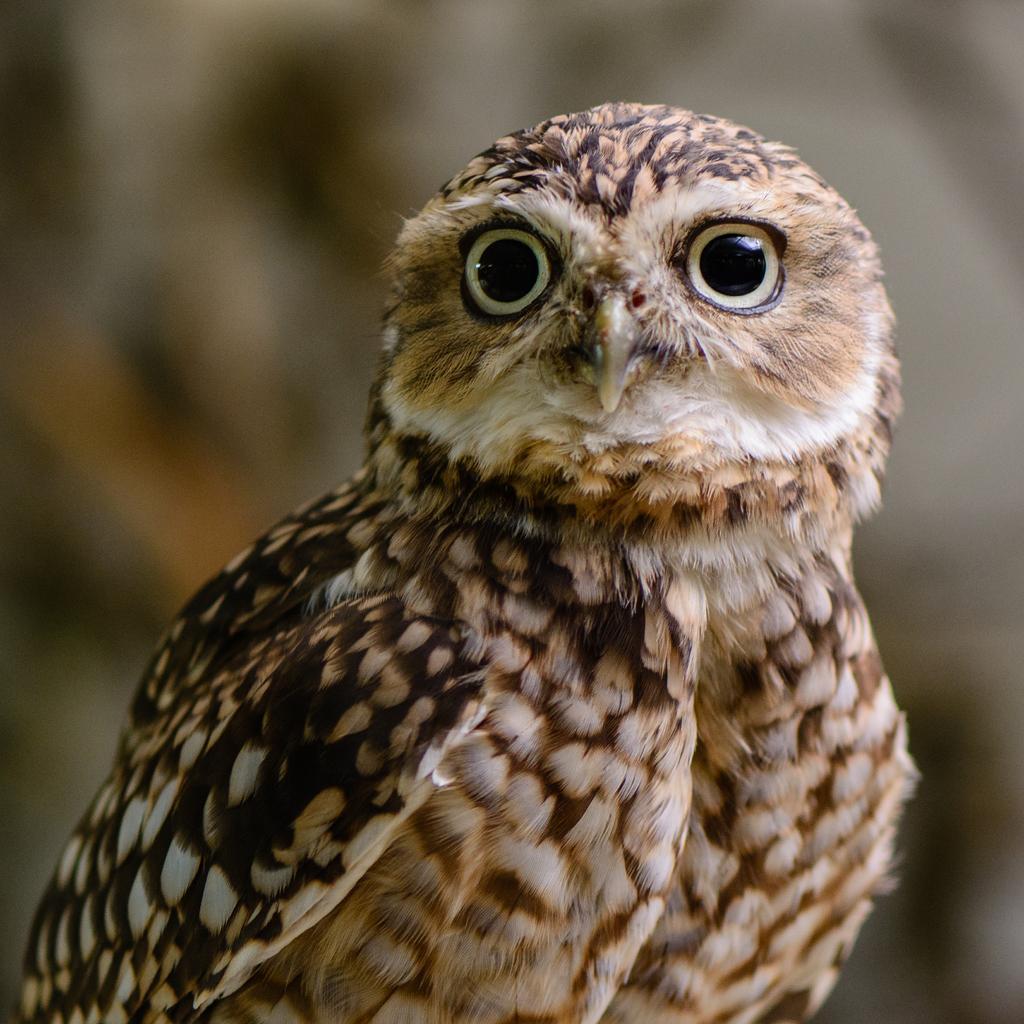Describe this image in one or two sentences. In this image in the foreground there is an owl, and the background is blurred. 